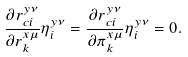<formula> <loc_0><loc_0><loc_500><loc_500>\frac { \partial r ^ { y \nu } _ { c i } } { \partial r _ { k } ^ { x \mu } } \eta ^ { y \nu } _ { i } = \frac { \partial r ^ { y \nu } _ { c i } } { \partial \pi _ { k } ^ { x \mu } } \eta ^ { y \nu } _ { i } = 0 .</formula> 